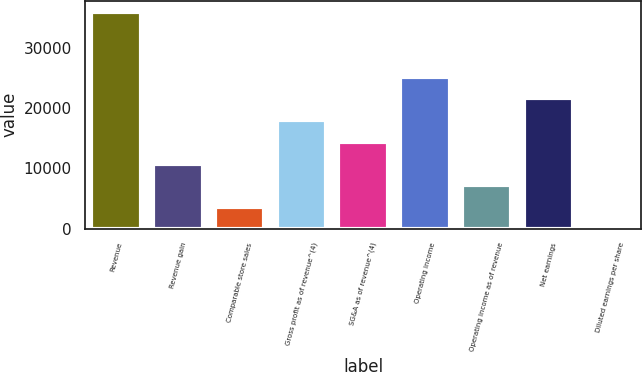Convert chart. <chart><loc_0><loc_0><loc_500><loc_500><bar_chart><fcel>Revenue<fcel>Revenue gain<fcel>Comparable store sales<fcel>Gross profit as of revenue^(4)<fcel>SG&A as of revenue^(4)<fcel>Operating income<fcel>Operating income as of revenue<fcel>Net earnings<fcel>Diluted earnings per share<nl><fcel>35934<fcel>10782.1<fcel>3595.91<fcel>17968.4<fcel>14375.3<fcel>25154.6<fcel>7189.03<fcel>21561.5<fcel>2.79<nl></chart> 